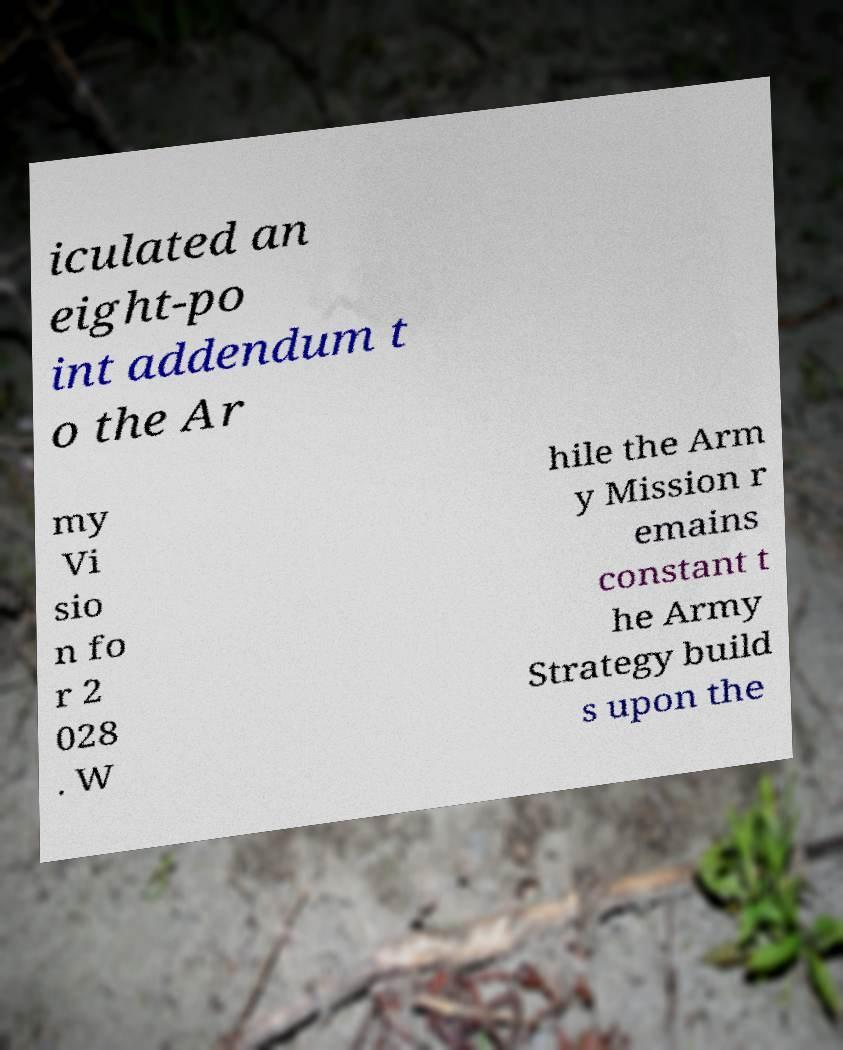What messages or text are displayed in this image? I need them in a readable, typed format. iculated an eight-po int addendum t o the Ar my Vi sio n fo r 2 028 . W hile the Arm y Mission r emains constant t he Army Strategy build s upon the 